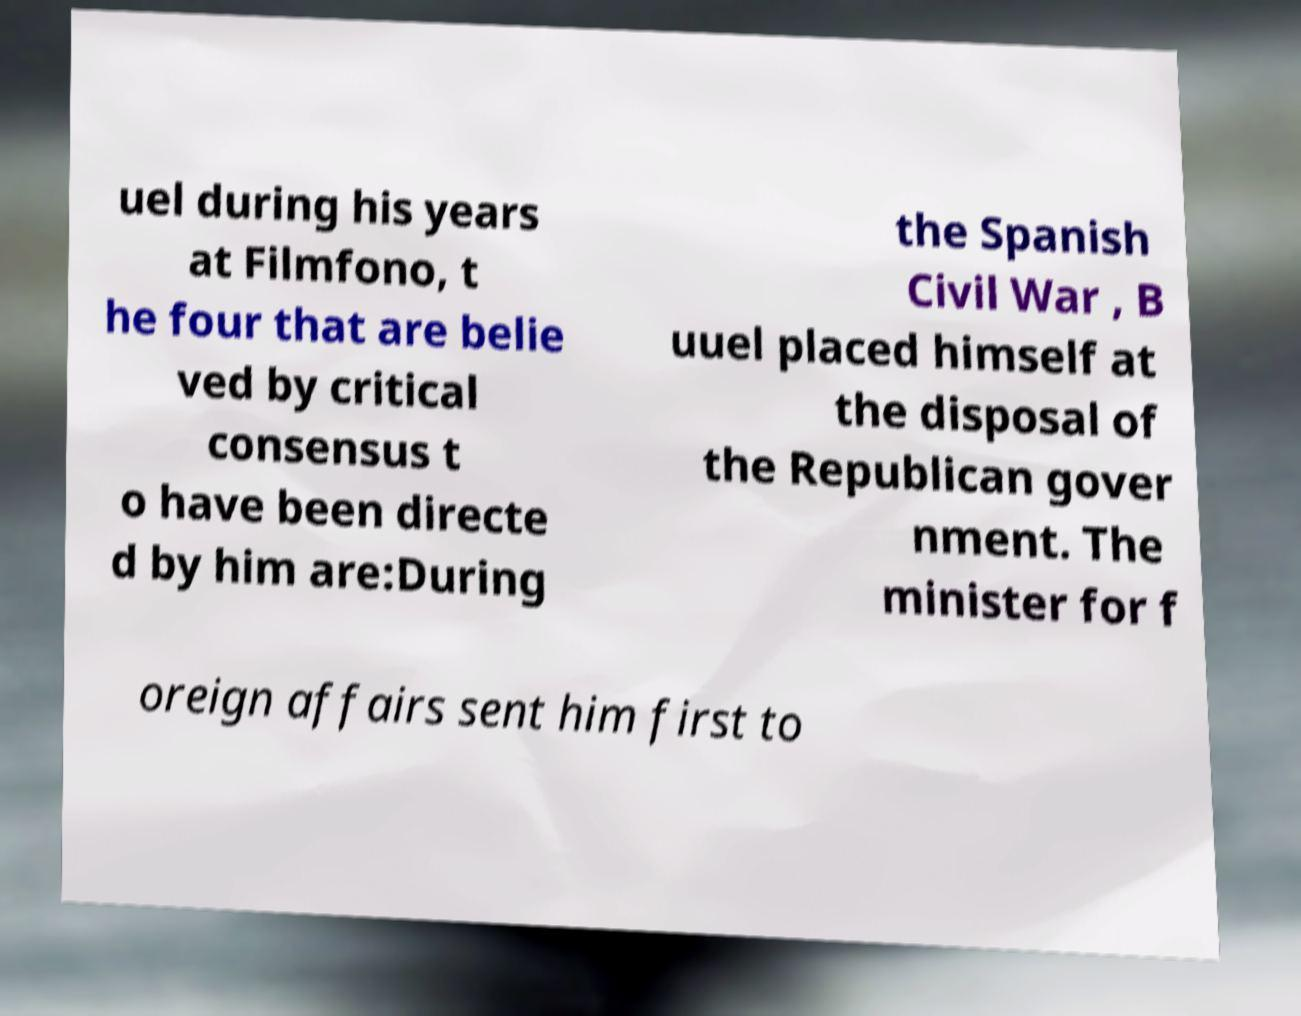Could you extract and type out the text from this image? uel during his years at Filmfono, t he four that are belie ved by critical consensus t o have been directe d by him are:During the Spanish Civil War , B uuel placed himself at the disposal of the Republican gover nment. The minister for f oreign affairs sent him first to 